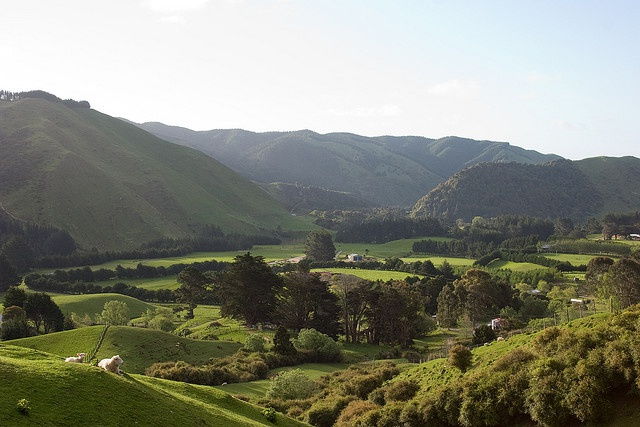Describe the objects in this image and their specific colors. I can see sheep in white, gray, ivory, and black tones and sheep in white, tan, olive, and gray tones in this image. 